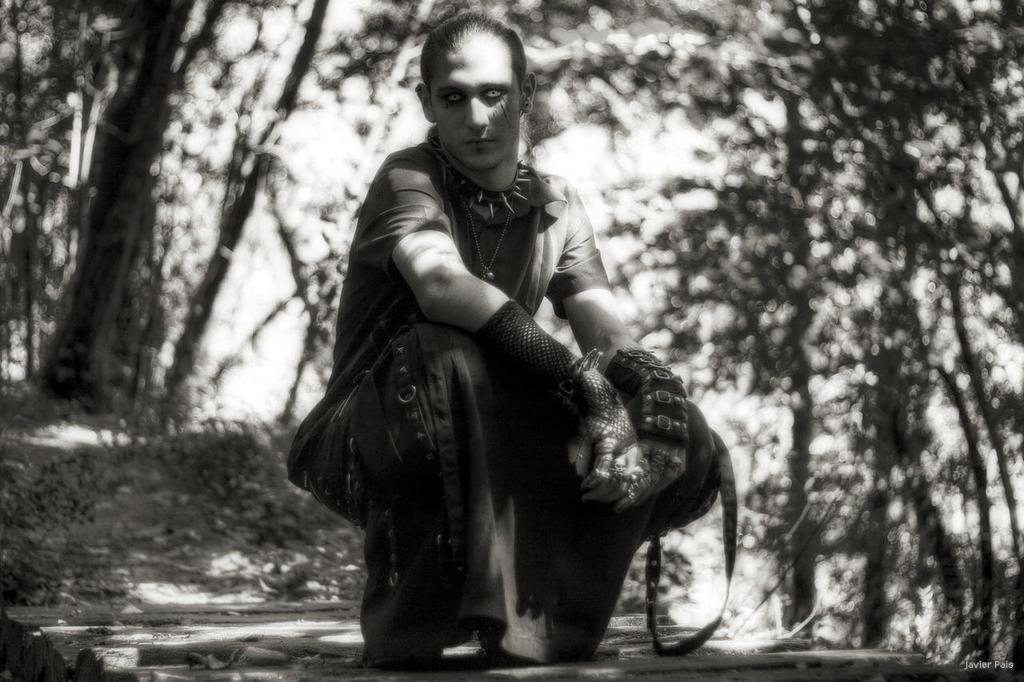What is the color scheme of the image? The image is black and white. What can be seen on the land in the image? There is a person sitting on the land in the image. What type of vegetation is present in the image? Trees are present in the image. What type of garden can be seen in the image? There is no garden present in the image; it features a person sitting on the land and trees. What type of farmer is visible in the image? There is no farmer present in the image. 